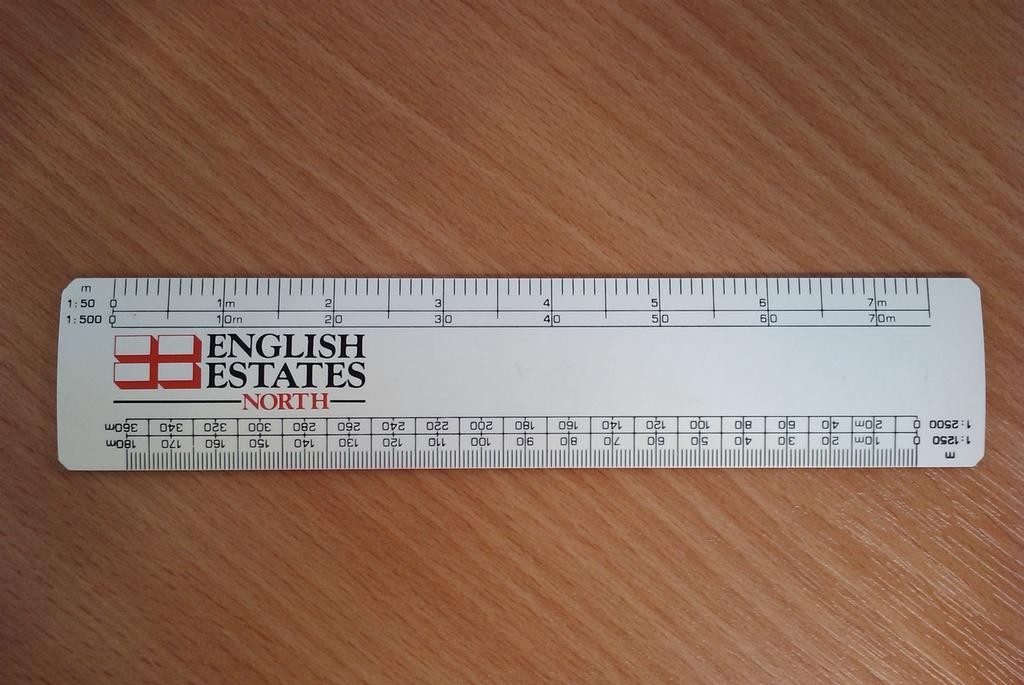<image>
Render a clear and concise summary of the photo. A white ruler sponsored by English Estates North sitting on a lightly colored wooden table. 